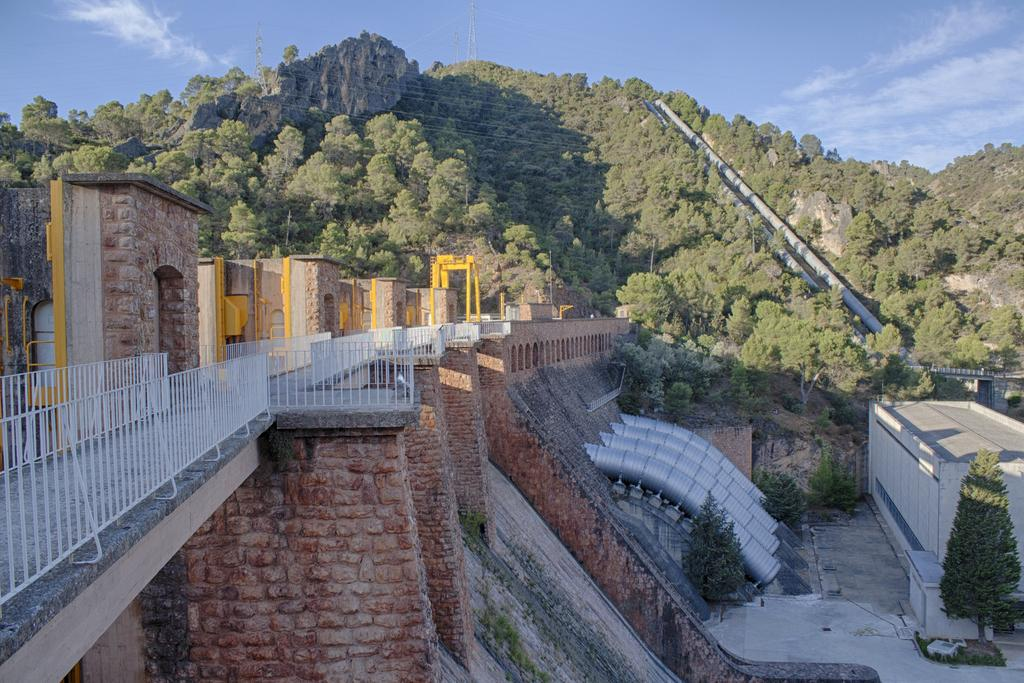What type of structure can be seen in the image? There is a dam in the image. What other structures are present in the image? There are shelters, a shed, a bridge, and railings in the image. What type of natural features can be seen in the image? There are trees and hills in the image. What man-made features can be seen in the image? There are pipes in the image. What is visible in the background of the image? The sky is visible in the background of the image. How many bags of grain can be seen in the image? There is no grain present in the image. What type of cart is used to transport goods in the image? There is no cart present in the image. 